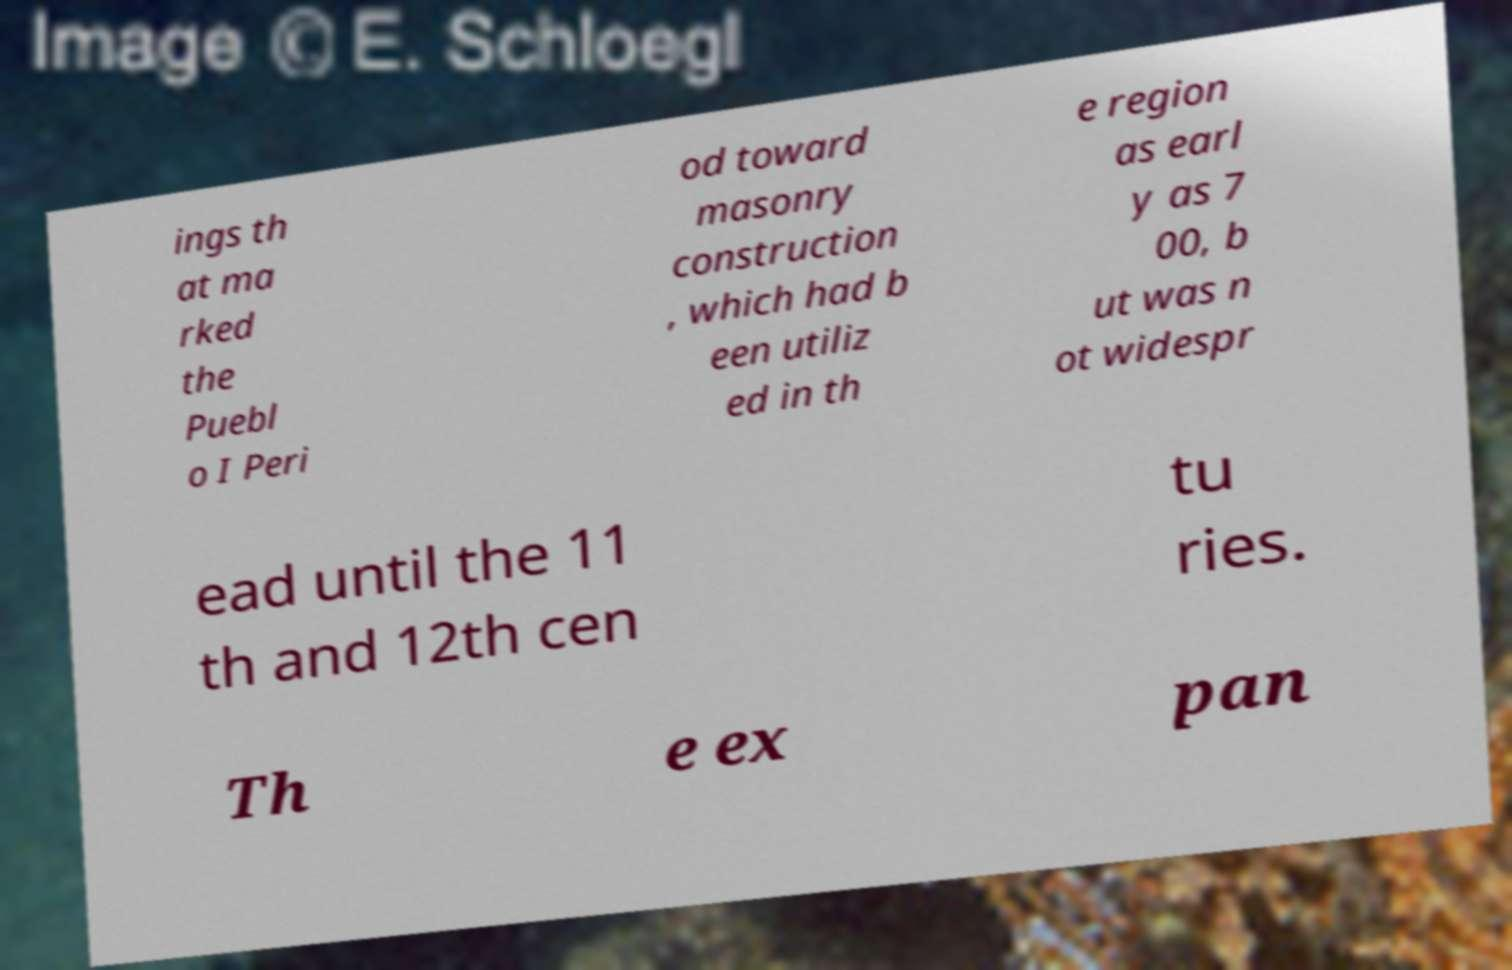I need the written content from this picture converted into text. Can you do that? ings th at ma rked the Puebl o I Peri od toward masonry construction , which had b een utiliz ed in th e region as earl y as 7 00, b ut was n ot widespr ead until the 11 th and 12th cen tu ries. Th e ex pan 